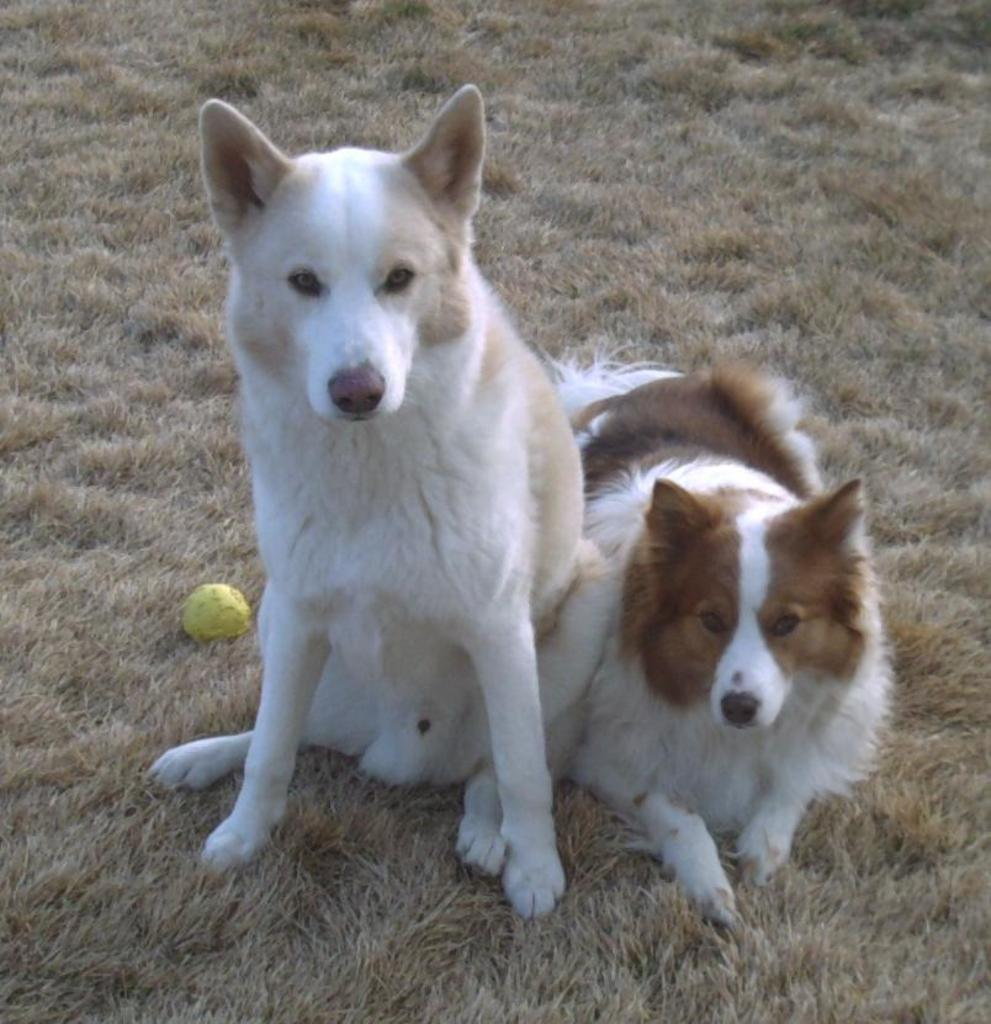How many dogs are in the image? There are two dogs in the image. What object is present in the image besides the dogs? There is a ball in the image. Where is the ball located? The ball is on the grass. What riddle can be solved by the dogs in the image? There is no riddle present in the image, as it features two dogs and a ball on the grass. 